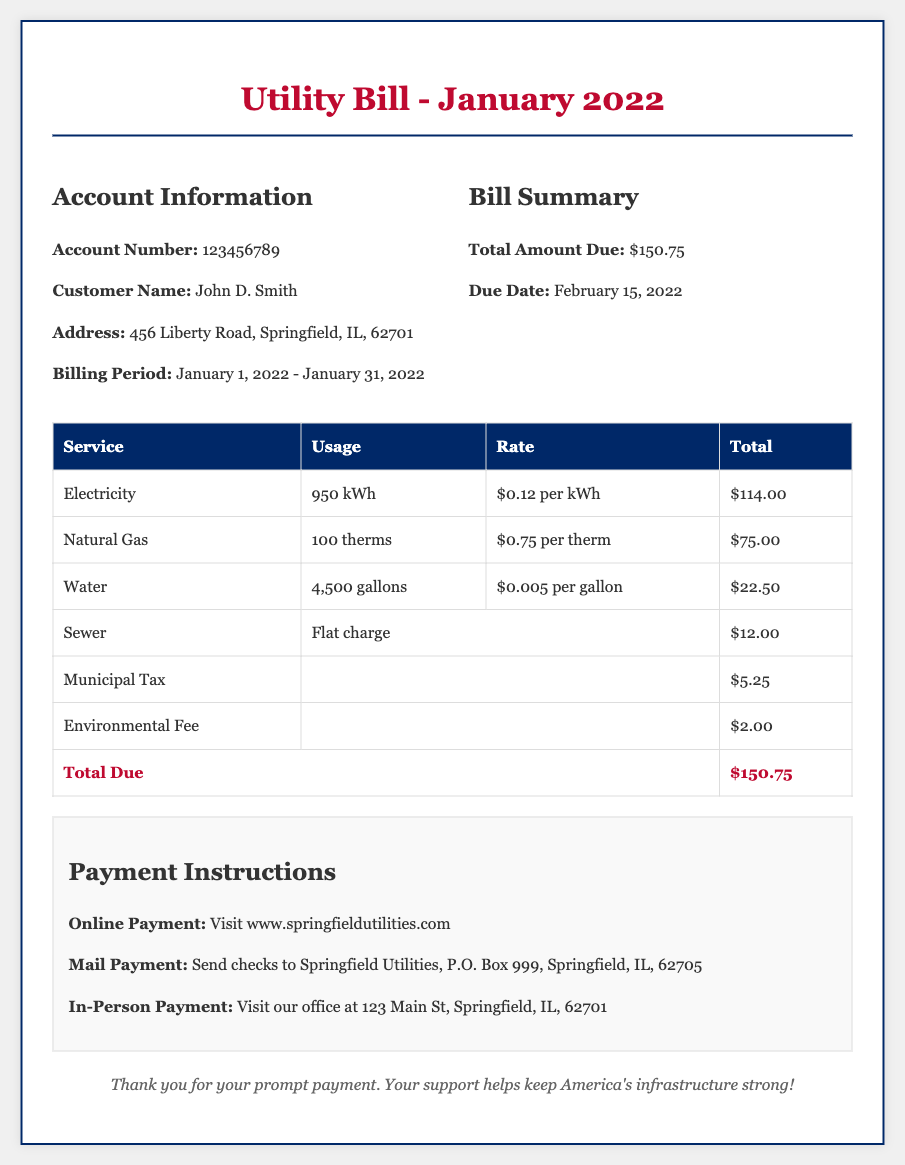What is the account number? The account number is specifically listed under Account Information in the document.
Answer: 123456789 Who is the customer? The name of the customer is clearly stated in the Account Information section of the document.
Answer: John D. Smith What is the billing period? The billing period is outlined in the Account Information section with specific dates.
Answer: January 1, 2022 - January 31, 2022 How much is the total amount due? The total amount due is prominently displayed in the Bill Summary section.
Answer: $150.75 What is the payment due date? The due date for payment is provided in the Bill Summary section.
Answer: February 15, 2022 What was the usage for Electricity? The usage for Electricity is detailed in the table for that specific service.
Answer: 950 kWh What is the rate per therm for Natural Gas? The rate for Natural Gas is indicated in the service details of the table.
Answer: $0.75 per therm How much is the Environmental Fee? The fee is listed in the breakdown of charges in the table.
Answer: $2.00 What type of charge is Sewer listed as? The nature of the Sewer charge is specified in the table under the service details.
Answer: Flat charge 